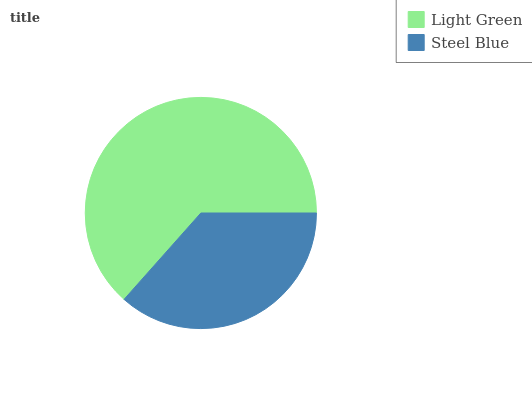Is Steel Blue the minimum?
Answer yes or no. Yes. Is Light Green the maximum?
Answer yes or no. Yes. Is Steel Blue the maximum?
Answer yes or no. No. Is Light Green greater than Steel Blue?
Answer yes or no. Yes. Is Steel Blue less than Light Green?
Answer yes or no. Yes. Is Steel Blue greater than Light Green?
Answer yes or no. No. Is Light Green less than Steel Blue?
Answer yes or no. No. Is Light Green the high median?
Answer yes or no. Yes. Is Steel Blue the low median?
Answer yes or no. Yes. Is Steel Blue the high median?
Answer yes or no. No. Is Light Green the low median?
Answer yes or no. No. 